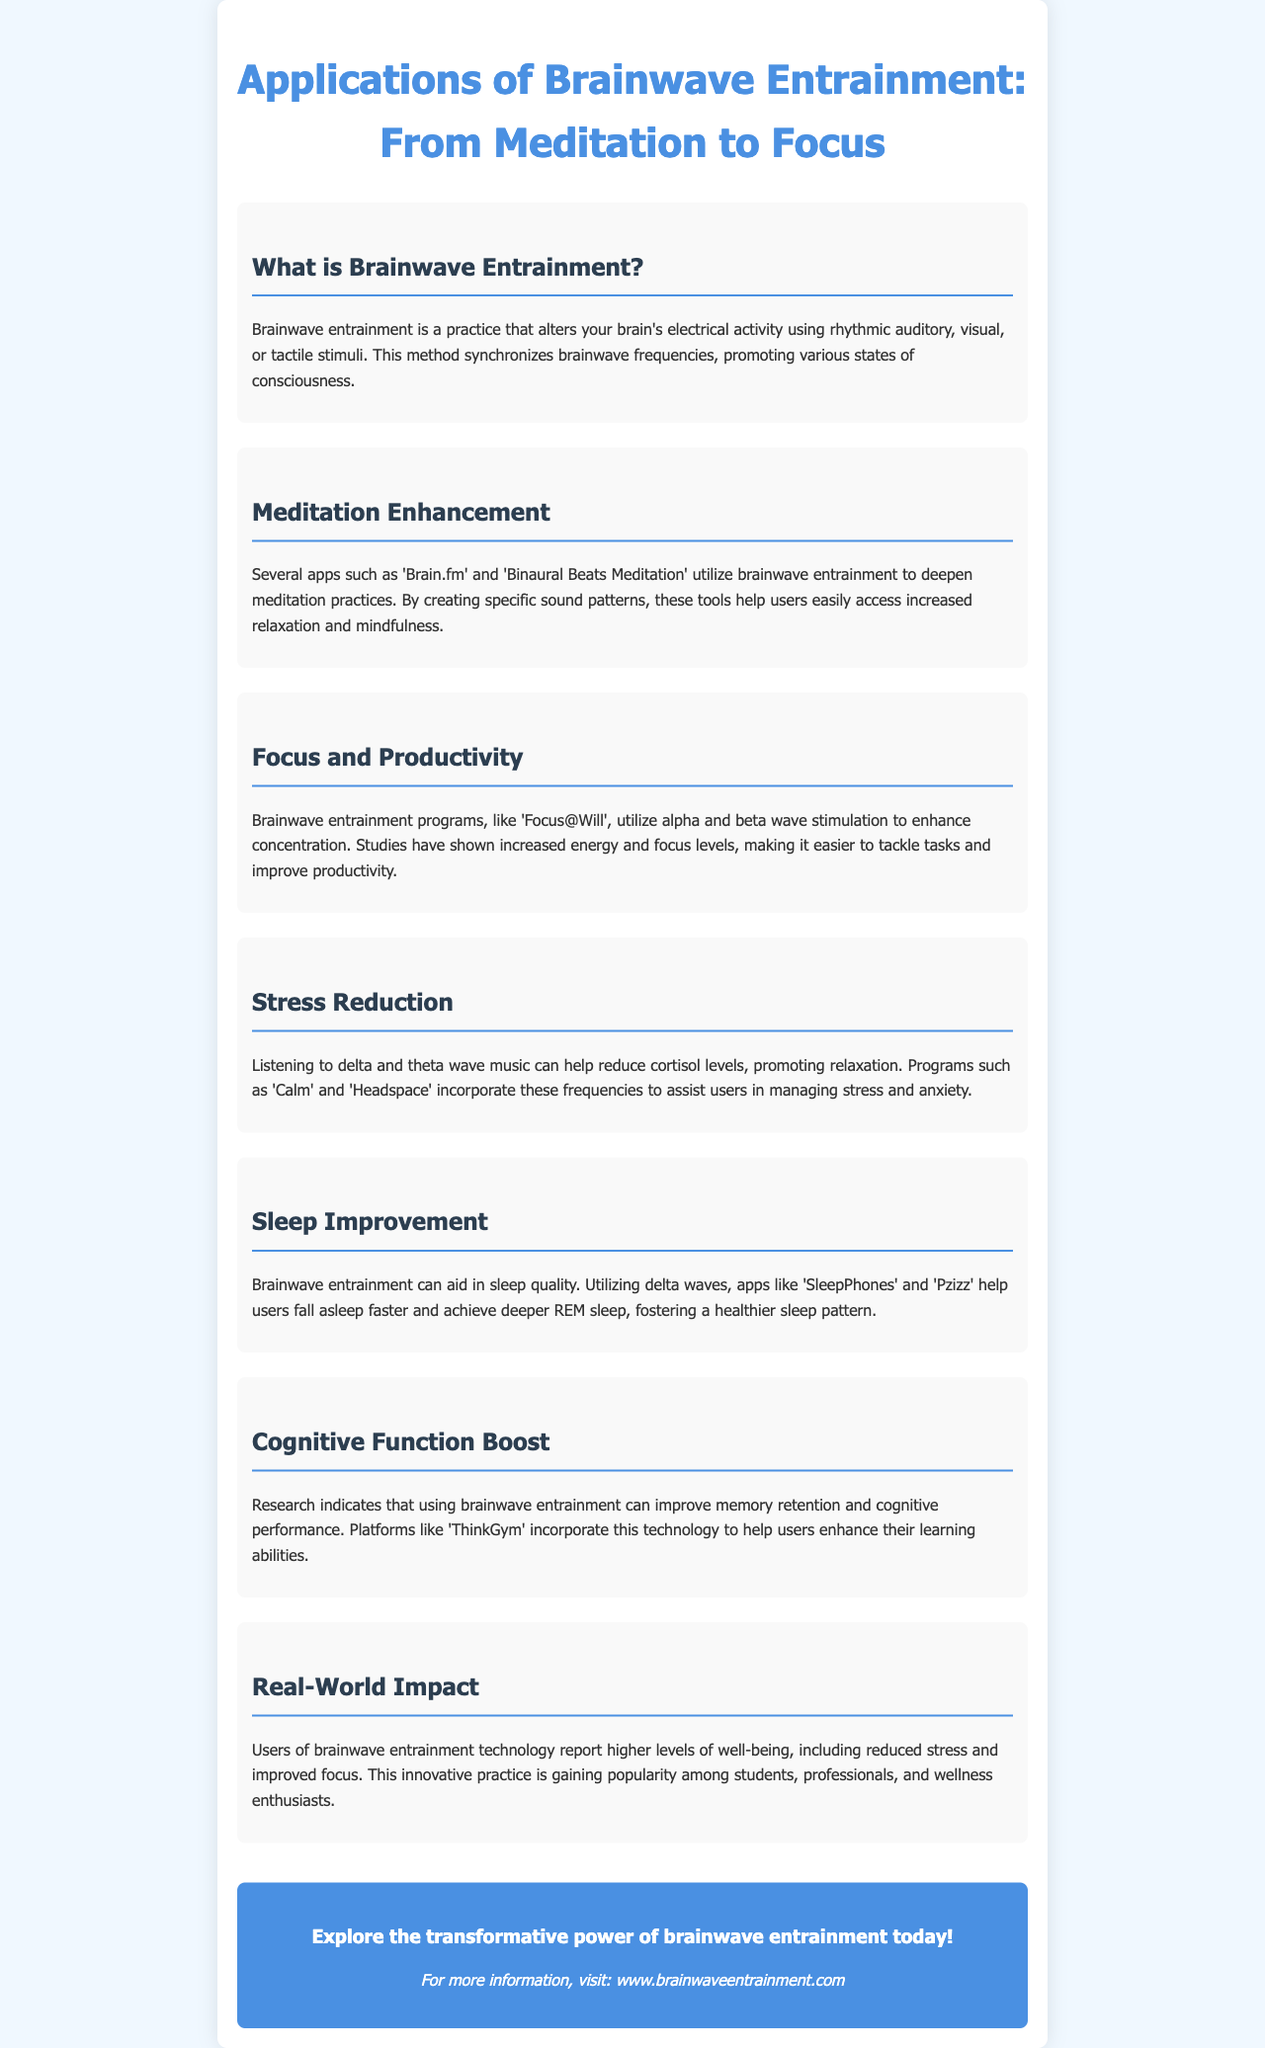What is brainwave entrainment? Brainwave entrainment is defined in the document as a practice that alters your brain's electrical activity using rhythmic auditory, visual, or tactile stimuli.
Answer: A practice that alters your brain's electrical activity Which apps are mentioned for meditation enhancement? The document lists apps specifically designed for meditation enhancement.
Answer: Brain.fm and Binaural Beats Meditation What type of waves does brainwave entrainment use for stress reduction? The document specifies which type of brainwaves are focused on for reducing stress.
Answer: Delta and theta waves What is the main benefit of using 'Focus@Will'? This app's main benefit is highlighted regarding its impact on productivity.
Answer: Enhance concentration Which brainwave frequency is associated with sleep improvement? The document mentions the specific brainwave frequency that aids in sleep quality.
Answer: Delta waves What impact has brainwave entrainment technology had on users? Users' feedback about brainwave entrainment technology is mentioned in terms of its effects.
Answer: Higher levels of well-being What does the footer encourage readers to do? The footer section includes a call to action for readers related to brainwave entrainment.
Answer: Explore the transformative power of brainwave entrainment Which app is known for helping users to manage stress and anxiety? The document lists specific programs that help with stress management.
Answer: Calm and Headspace 